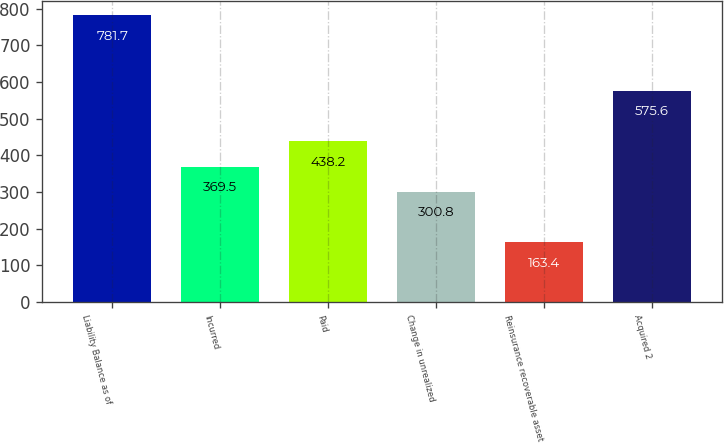Convert chart to OTSL. <chart><loc_0><loc_0><loc_500><loc_500><bar_chart><fcel>Liability Balance as of<fcel>Incurred<fcel>Paid<fcel>Change in unrealized<fcel>Reinsurance recoverable asset<fcel>Acquired 2<nl><fcel>781.7<fcel>369.5<fcel>438.2<fcel>300.8<fcel>163.4<fcel>575.6<nl></chart> 